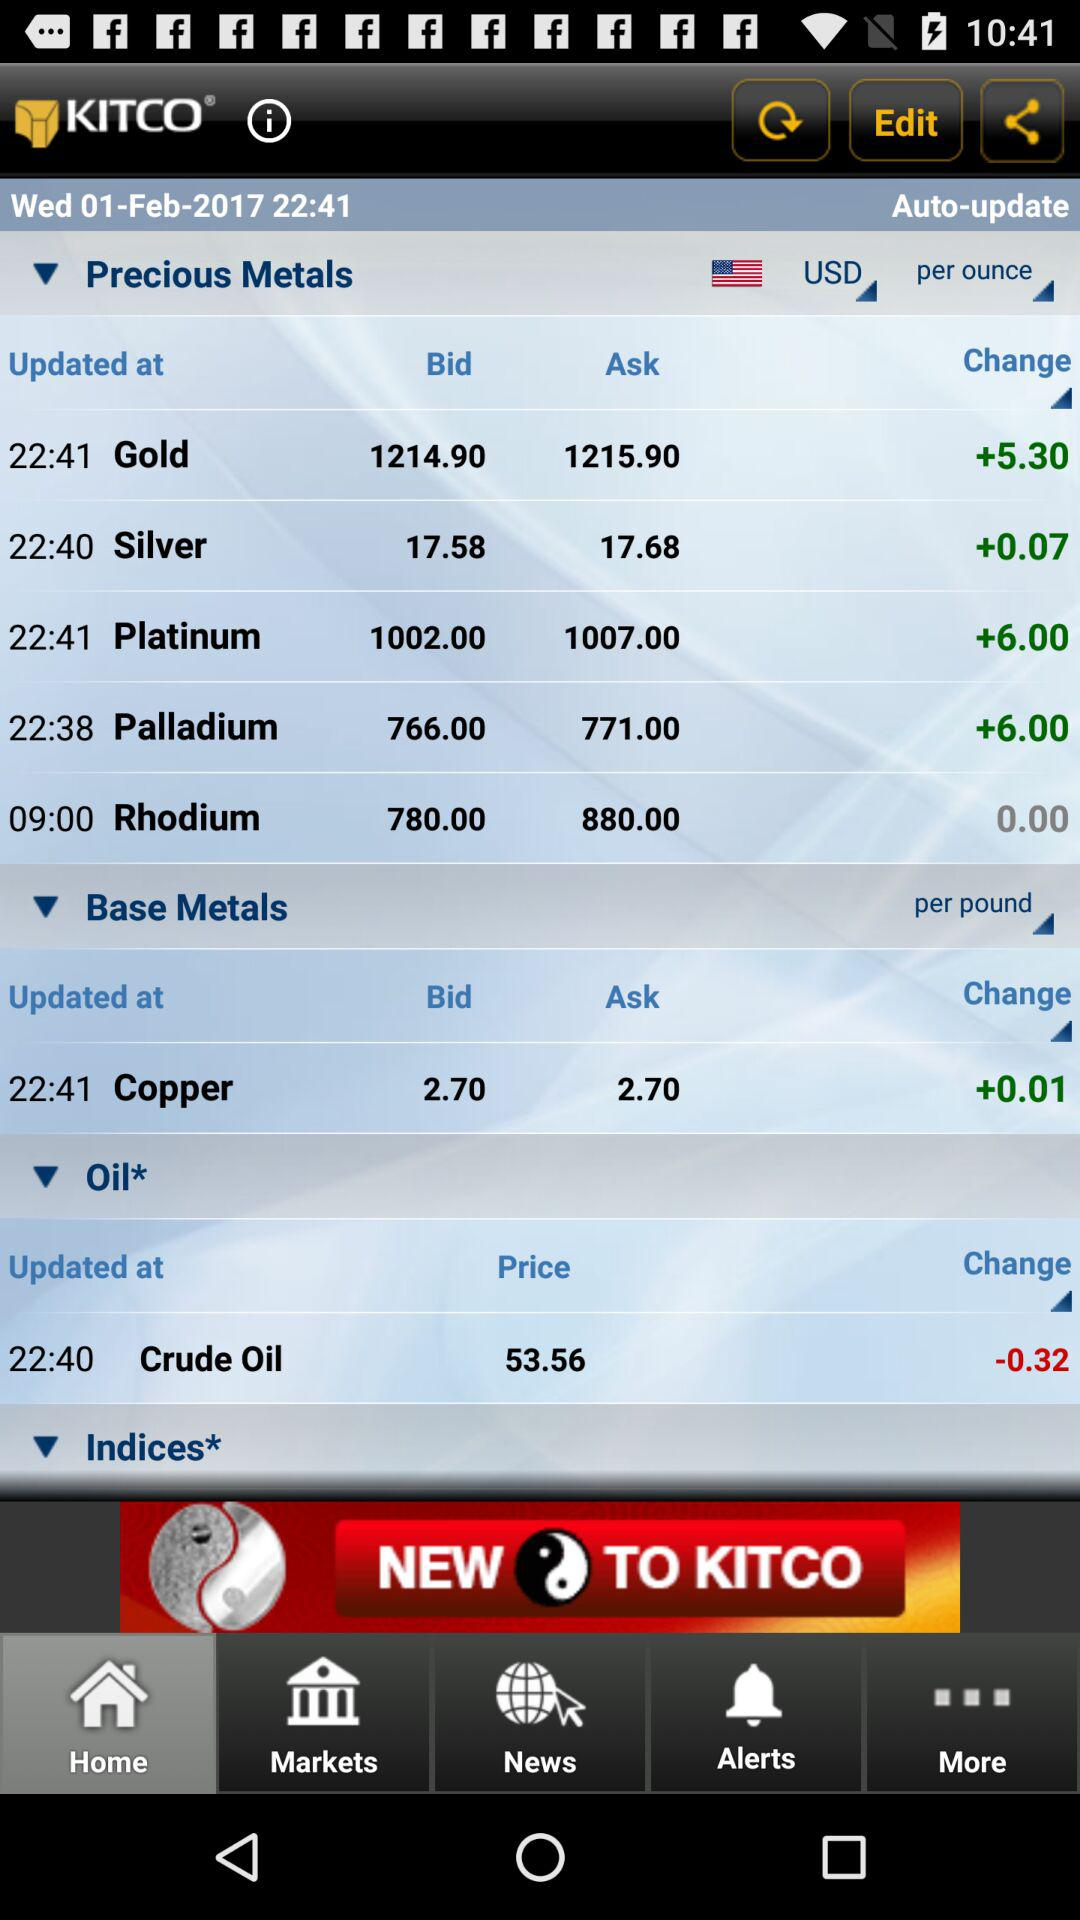Which tab has been selected? The tab that has been selected is "Home". 